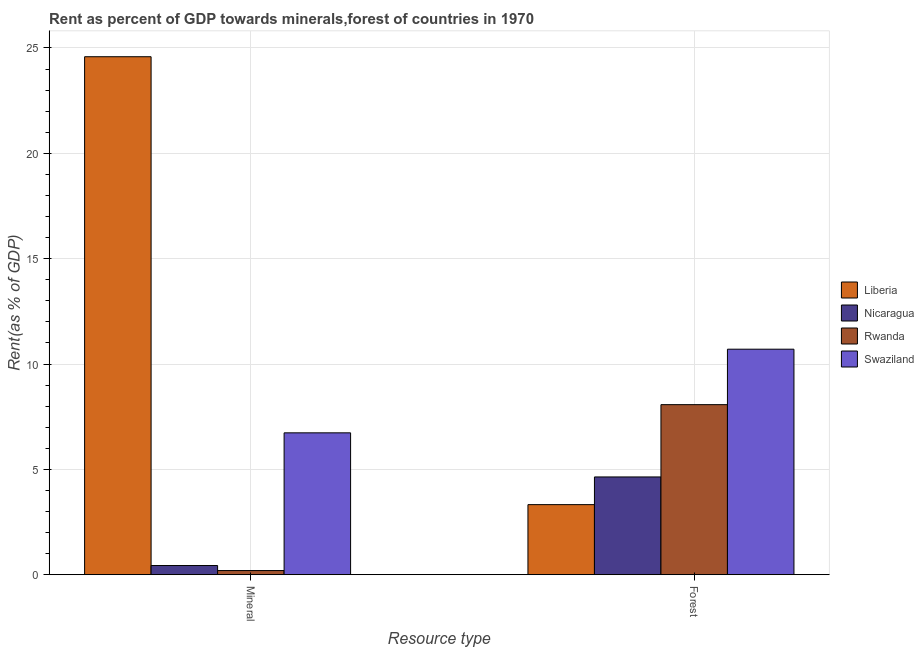How many different coloured bars are there?
Keep it short and to the point. 4. Are the number of bars per tick equal to the number of legend labels?
Offer a terse response. Yes. Are the number of bars on each tick of the X-axis equal?
Offer a terse response. Yes. How many bars are there on the 1st tick from the right?
Provide a short and direct response. 4. What is the label of the 1st group of bars from the left?
Keep it short and to the point. Mineral. What is the mineral rent in Liberia?
Make the answer very short. 24.59. Across all countries, what is the maximum mineral rent?
Make the answer very short. 24.59. Across all countries, what is the minimum mineral rent?
Offer a very short reply. 0.2. In which country was the forest rent maximum?
Offer a terse response. Swaziland. In which country was the forest rent minimum?
Your answer should be very brief. Liberia. What is the total forest rent in the graph?
Keep it short and to the point. 26.74. What is the difference between the forest rent in Liberia and that in Rwanda?
Offer a terse response. -4.75. What is the difference between the mineral rent in Rwanda and the forest rent in Swaziland?
Offer a very short reply. -10.51. What is the average mineral rent per country?
Make the answer very short. 7.99. What is the difference between the mineral rent and forest rent in Liberia?
Your response must be concise. 21.26. In how many countries, is the mineral rent greater than 18 %?
Provide a short and direct response. 1. What is the ratio of the mineral rent in Rwanda to that in Swaziland?
Your answer should be compact. 0.03. What does the 1st bar from the left in Mineral represents?
Your answer should be very brief. Liberia. What does the 1st bar from the right in Mineral represents?
Offer a terse response. Swaziland. Are all the bars in the graph horizontal?
Provide a succinct answer. No. How many countries are there in the graph?
Offer a very short reply. 4. What is the difference between two consecutive major ticks on the Y-axis?
Provide a short and direct response. 5. How are the legend labels stacked?
Keep it short and to the point. Vertical. What is the title of the graph?
Offer a very short reply. Rent as percent of GDP towards minerals,forest of countries in 1970. What is the label or title of the X-axis?
Provide a short and direct response. Resource type. What is the label or title of the Y-axis?
Offer a terse response. Rent(as % of GDP). What is the Rent(as % of GDP) in Liberia in Mineral?
Make the answer very short. 24.59. What is the Rent(as % of GDP) of Nicaragua in Mineral?
Provide a succinct answer. 0.43. What is the Rent(as % of GDP) of Rwanda in Mineral?
Keep it short and to the point. 0.2. What is the Rent(as % of GDP) of Swaziland in Mineral?
Give a very brief answer. 6.73. What is the Rent(as % of GDP) of Liberia in Forest?
Offer a very short reply. 3.33. What is the Rent(as % of GDP) of Nicaragua in Forest?
Give a very brief answer. 4.64. What is the Rent(as % of GDP) in Rwanda in Forest?
Your answer should be compact. 8.07. What is the Rent(as % of GDP) of Swaziland in Forest?
Your response must be concise. 10.7. Across all Resource type, what is the maximum Rent(as % of GDP) of Liberia?
Offer a terse response. 24.59. Across all Resource type, what is the maximum Rent(as % of GDP) in Nicaragua?
Keep it short and to the point. 4.64. Across all Resource type, what is the maximum Rent(as % of GDP) in Rwanda?
Your response must be concise. 8.07. Across all Resource type, what is the maximum Rent(as % of GDP) in Swaziland?
Keep it short and to the point. 10.7. Across all Resource type, what is the minimum Rent(as % of GDP) in Liberia?
Offer a terse response. 3.33. Across all Resource type, what is the minimum Rent(as % of GDP) of Nicaragua?
Make the answer very short. 0.43. Across all Resource type, what is the minimum Rent(as % of GDP) in Rwanda?
Provide a short and direct response. 0.2. Across all Resource type, what is the minimum Rent(as % of GDP) of Swaziland?
Provide a succinct answer. 6.73. What is the total Rent(as % of GDP) in Liberia in the graph?
Keep it short and to the point. 27.91. What is the total Rent(as % of GDP) in Nicaragua in the graph?
Make the answer very short. 5.07. What is the total Rent(as % of GDP) in Rwanda in the graph?
Provide a succinct answer. 8.27. What is the total Rent(as % of GDP) in Swaziland in the graph?
Your answer should be compact. 17.44. What is the difference between the Rent(as % of GDP) of Liberia in Mineral and that in Forest?
Provide a succinct answer. 21.26. What is the difference between the Rent(as % of GDP) of Nicaragua in Mineral and that in Forest?
Ensure brevity in your answer.  -4.2. What is the difference between the Rent(as % of GDP) of Rwanda in Mineral and that in Forest?
Offer a very short reply. -7.87. What is the difference between the Rent(as % of GDP) in Swaziland in Mineral and that in Forest?
Offer a terse response. -3.97. What is the difference between the Rent(as % of GDP) in Liberia in Mineral and the Rent(as % of GDP) in Nicaragua in Forest?
Offer a very short reply. 19.95. What is the difference between the Rent(as % of GDP) in Liberia in Mineral and the Rent(as % of GDP) in Rwanda in Forest?
Your answer should be compact. 16.51. What is the difference between the Rent(as % of GDP) in Liberia in Mineral and the Rent(as % of GDP) in Swaziland in Forest?
Offer a terse response. 13.88. What is the difference between the Rent(as % of GDP) of Nicaragua in Mineral and the Rent(as % of GDP) of Rwanda in Forest?
Give a very brief answer. -7.64. What is the difference between the Rent(as % of GDP) in Nicaragua in Mineral and the Rent(as % of GDP) in Swaziland in Forest?
Your answer should be very brief. -10.27. What is the difference between the Rent(as % of GDP) in Rwanda in Mineral and the Rent(as % of GDP) in Swaziland in Forest?
Keep it short and to the point. -10.51. What is the average Rent(as % of GDP) in Liberia per Resource type?
Offer a very short reply. 13.96. What is the average Rent(as % of GDP) of Nicaragua per Resource type?
Keep it short and to the point. 2.54. What is the average Rent(as % of GDP) in Rwanda per Resource type?
Offer a very short reply. 4.13. What is the average Rent(as % of GDP) of Swaziland per Resource type?
Offer a terse response. 8.72. What is the difference between the Rent(as % of GDP) of Liberia and Rent(as % of GDP) of Nicaragua in Mineral?
Your answer should be very brief. 24.15. What is the difference between the Rent(as % of GDP) of Liberia and Rent(as % of GDP) of Rwanda in Mineral?
Your response must be concise. 24.39. What is the difference between the Rent(as % of GDP) in Liberia and Rent(as % of GDP) in Swaziland in Mineral?
Provide a short and direct response. 17.85. What is the difference between the Rent(as % of GDP) in Nicaragua and Rent(as % of GDP) in Rwanda in Mineral?
Offer a terse response. 0.24. What is the difference between the Rent(as % of GDP) of Nicaragua and Rent(as % of GDP) of Swaziland in Mineral?
Your answer should be compact. -6.3. What is the difference between the Rent(as % of GDP) in Rwanda and Rent(as % of GDP) in Swaziland in Mineral?
Make the answer very short. -6.54. What is the difference between the Rent(as % of GDP) of Liberia and Rent(as % of GDP) of Nicaragua in Forest?
Your answer should be compact. -1.31. What is the difference between the Rent(as % of GDP) of Liberia and Rent(as % of GDP) of Rwanda in Forest?
Offer a very short reply. -4.75. What is the difference between the Rent(as % of GDP) in Liberia and Rent(as % of GDP) in Swaziland in Forest?
Your answer should be very brief. -7.38. What is the difference between the Rent(as % of GDP) in Nicaragua and Rent(as % of GDP) in Rwanda in Forest?
Your response must be concise. -3.43. What is the difference between the Rent(as % of GDP) of Nicaragua and Rent(as % of GDP) of Swaziland in Forest?
Offer a very short reply. -6.06. What is the difference between the Rent(as % of GDP) in Rwanda and Rent(as % of GDP) in Swaziland in Forest?
Keep it short and to the point. -2.63. What is the ratio of the Rent(as % of GDP) in Liberia in Mineral to that in Forest?
Provide a short and direct response. 7.39. What is the ratio of the Rent(as % of GDP) in Nicaragua in Mineral to that in Forest?
Provide a short and direct response. 0.09. What is the ratio of the Rent(as % of GDP) in Rwanda in Mineral to that in Forest?
Offer a very short reply. 0.02. What is the ratio of the Rent(as % of GDP) in Swaziland in Mineral to that in Forest?
Give a very brief answer. 0.63. What is the difference between the highest and the second highest Rent(as % of GDP) of Liberia?
Ensure brevity in your answer.  21.26. What is the difference between the highest and the second highest Rent(as % of GDP) of Nicaragua?
Provide a succinct answer. 4.2. What is the difference between the highest and the second highest Rent(as % of GDP) of Rwanda?
Provide a succinct answer. 7.87. What is the difference between the highest and the second highest Rent(as % of GDP) of Swaziland?
Provide a succinct answer. 3.97. What is the difference between the highest and the lowest Rent(as % of GDP) in Liberia?
Give a very brief answer. 21.26. What is the difference between the highest and the lowest Rent(as % of GDP) in Nicaragua?
Offer a very short reply. 4.2. What is the difference between the highest and the lowest Rent(as % of GDP) in Rwanda?
Offer a very short reply. 7.87. What is the difference between the highest and the lowest Rent(as % of GDP) of Swaziland?
Offer a terse response. 3.97. 